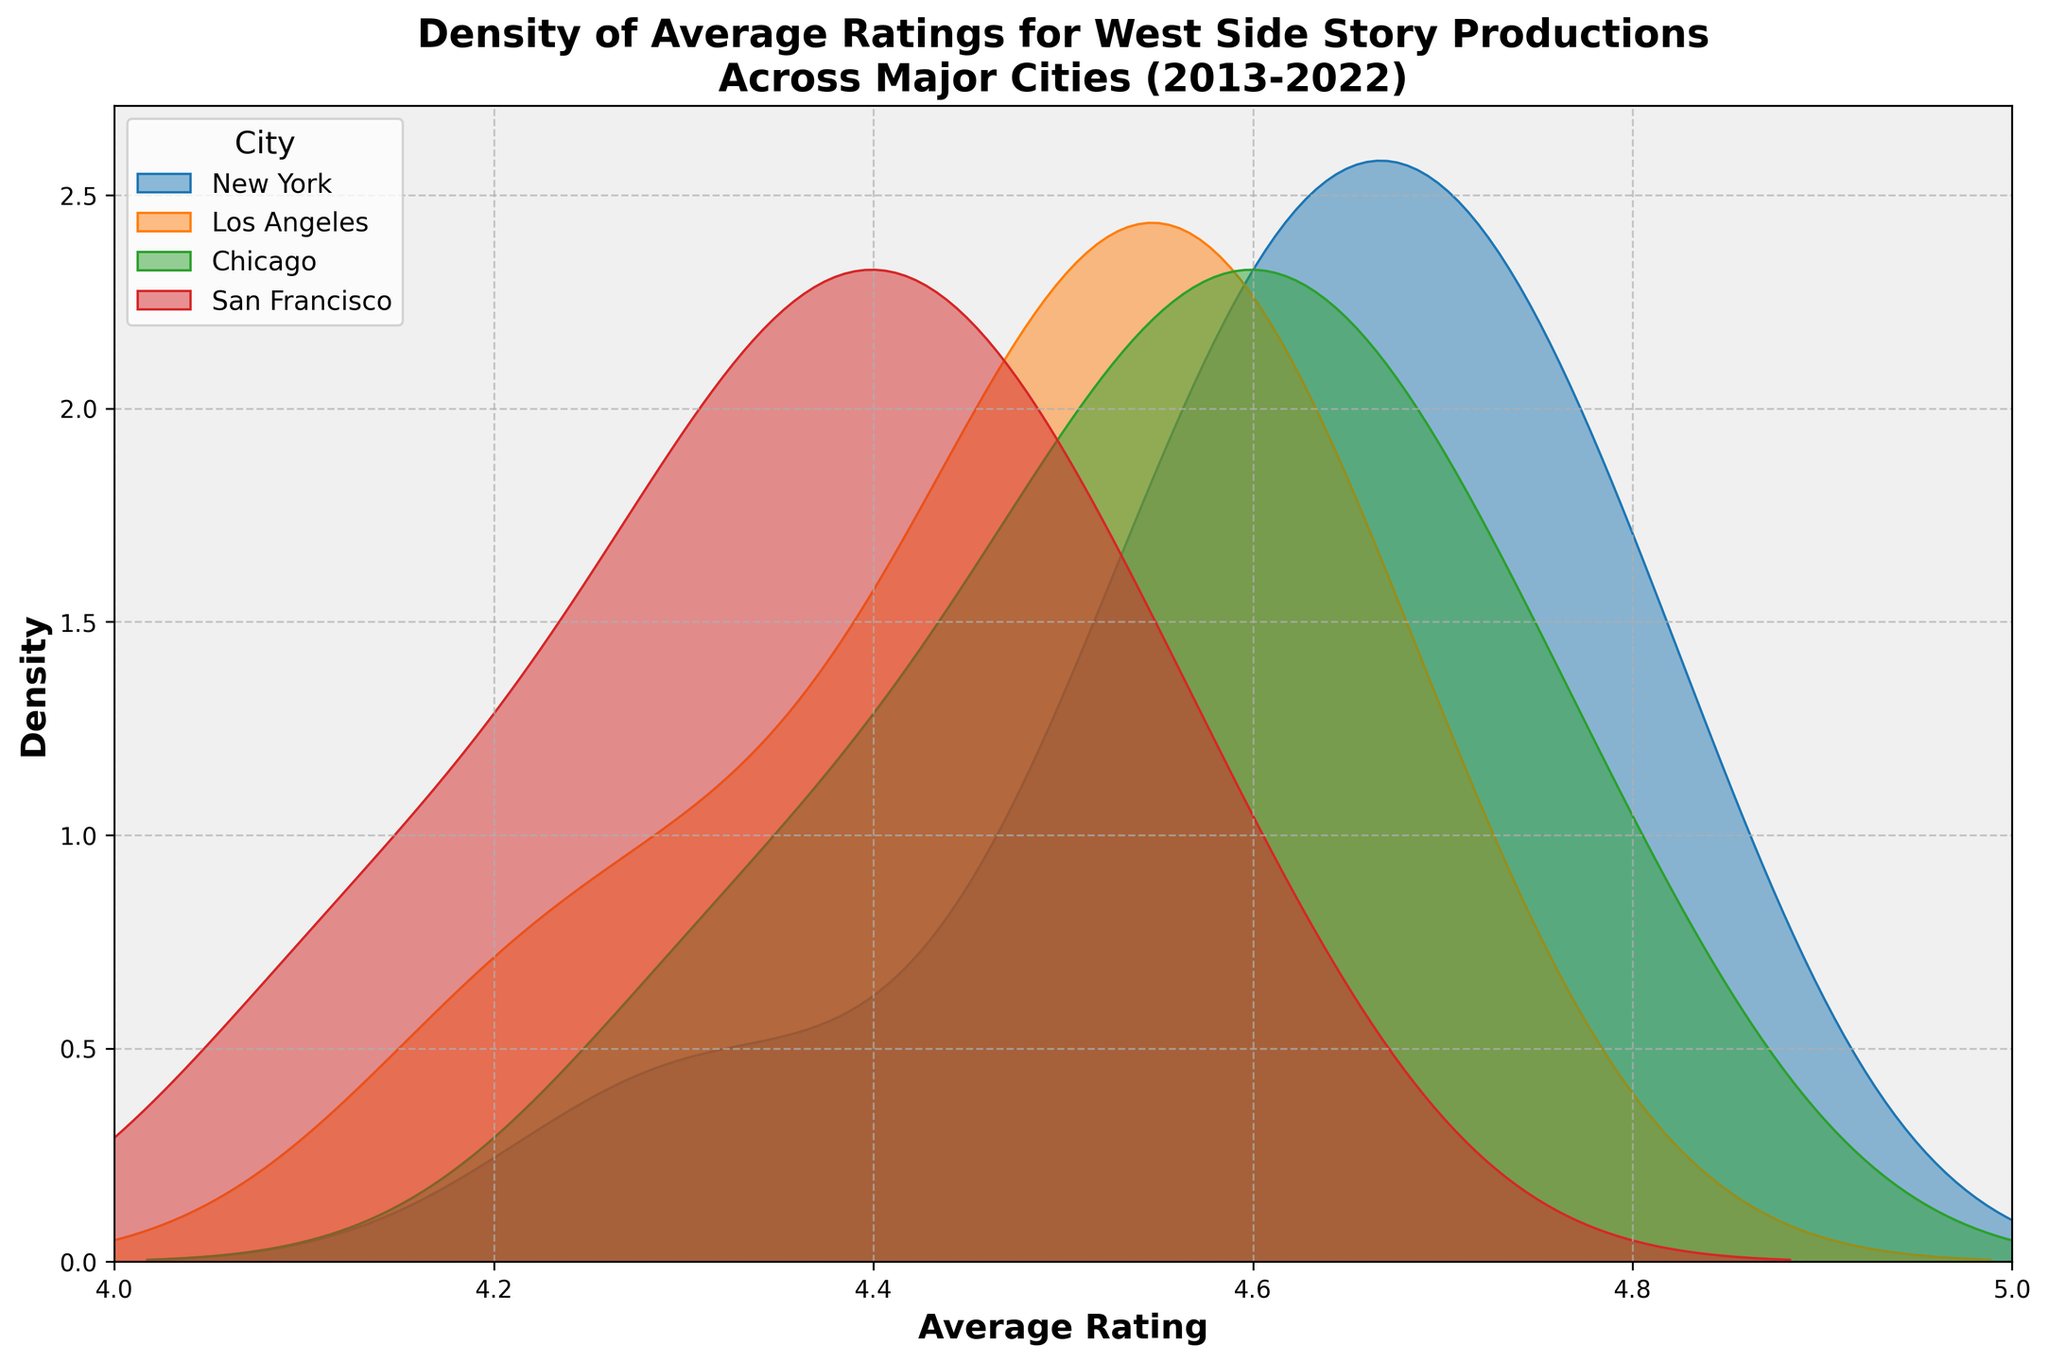What's the title of the plot? Look at the text displayed at the top of the plot which summarizes the overall description of the figure. The title is usually in a larger and bolder font.
Answer: Density of Average Ratings for West Side Story Productions Across Major Cities (2013-2022) What is the label of the x-axis? Check the label written along the horizontal axis of the plot. This label indicates what the x-axis represents.
Answer: Average Rating What is the label of the y-axis? Look for the label written along the vertical axis of the plot. This label indicates what the y-axis represents.
Answer: Density Which city shows the highest density peak? Observe the densest part of each density plot (the highest peak) to determine which city has the highest peak.
Answer: New York Which city has the lowest rating peak? Compare the lowest points of each city's density curve to find the city with the peak closest to 4.0.
Answer: San Francisco How do the ratings distributions of New York and Los Angeles compare in terms of spread? Analyze the widths of the density curves for New York and Los Angeles to determine how spread out each city's ratings are. New York has a slightly wider spread indicating more variability in its ratings.
Answer: New York is wider; Los Angeles is narrower In which year(s) did the ratings dip significantly for most cities? Look for a common dip in the density distributions of multiple cities. Dips in 2020 are notably lower compared to other years.
Answer: 2020 What is the x-axis range for the plot? Examine the scale of the x-axis to find the minimum and maximum values it covers.
Answer: 4.0 to 5.0 What's the relationship between the highest rating peak and the city's time trend? Determine which city has the highest peak and then look at its average ratings over time to understand if the city has an overall increasing, decreasing, or stable trend. New York's increasing rating trend over the years aligns with its high peak.
Answer: New York's peak aligns with an increasing trend 